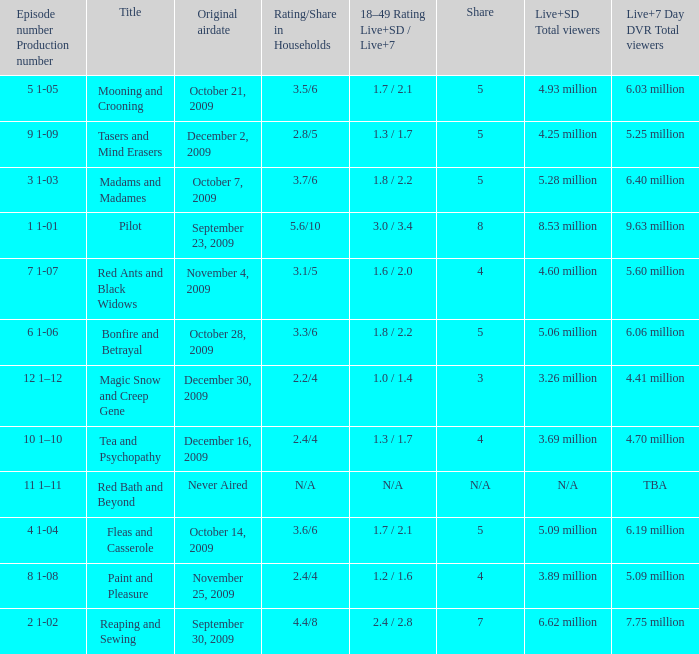When did the fourth episode of the season (4 1-04) first air? October 14, 2009. 